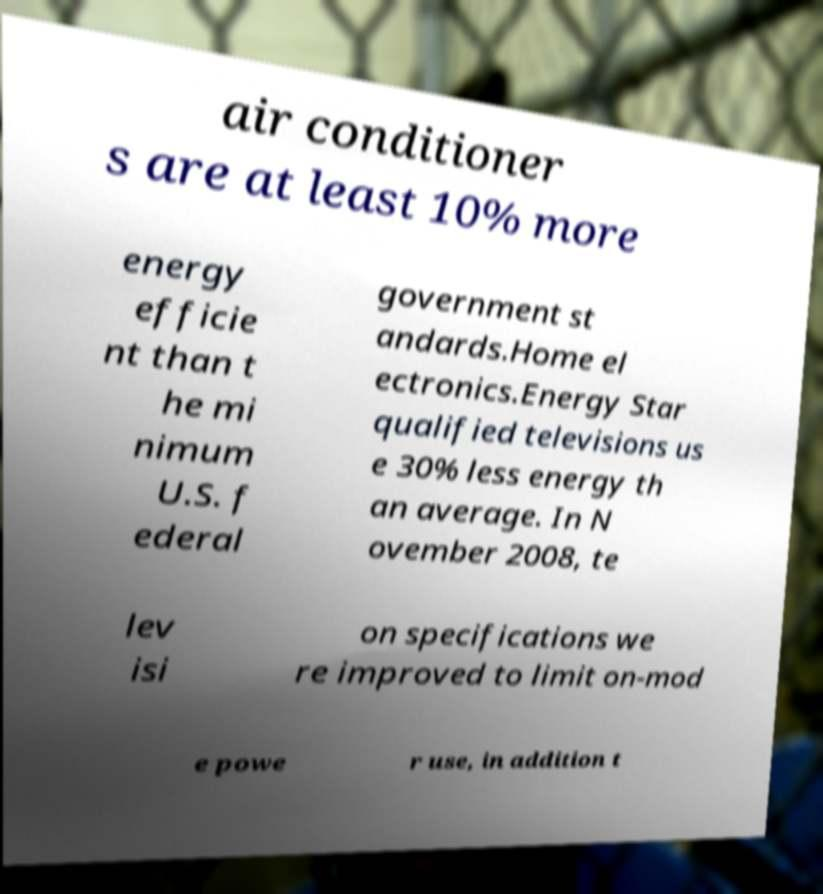Can you accurately transcribe the text from the provided image for me? air conditioner s are at least 10% more energy efficie nt than t he mi nimum U.S. f ederal government st andards.Home el ectronics.Energy Star qualified televisions us e 30% less energy th an average. In N ovember 2008, te lev isi on specifications we re improved to limit on-mod e powe r use, in addition t 